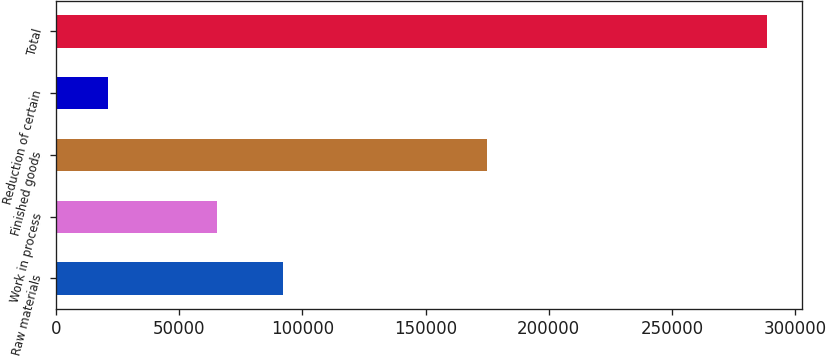Convert chart. <chart><loc_0><loc_0><loc_500><loc_500><bar_chart><fcel>Raw materials<fcel>Work in process<fcel>Finished goods<fcel>Reduction of certain<fcel>Total<nl><fcel>91919.2<fcel>65148<fcel>174968<fcel>20858<fcel>288570<nl></chart> 